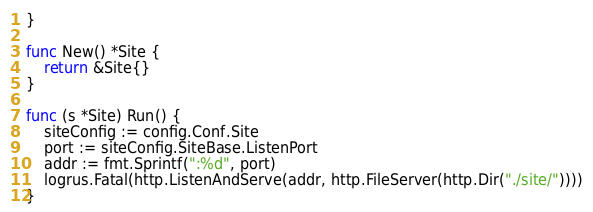<code> <loc_0><loc_0><loc_500><loc_500><_Go_>}

func New() *Site {
	return &Site{}
}

func (s *Site) Run() {
	siteConfig := config.Conf.Site
	port := siteConfig.SiteBase.ListenPort
	addr := fmt.Sprintf(":%d", port)
	logrus.Fatal(http.ListenAndServe(addr, http.FileServer(http.Dir("./site/"))))
}
</code> 